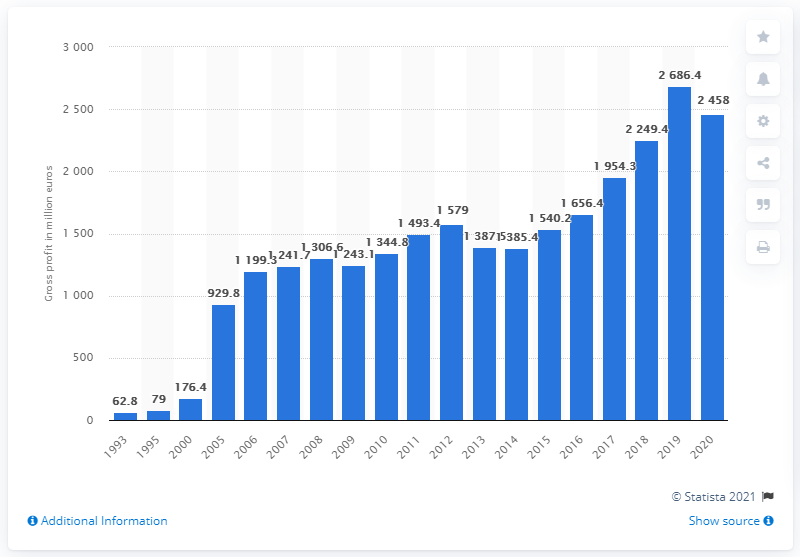Indicate a few pertinent items in this graphic. In 2020, Puma's gross profit was 2,458. 